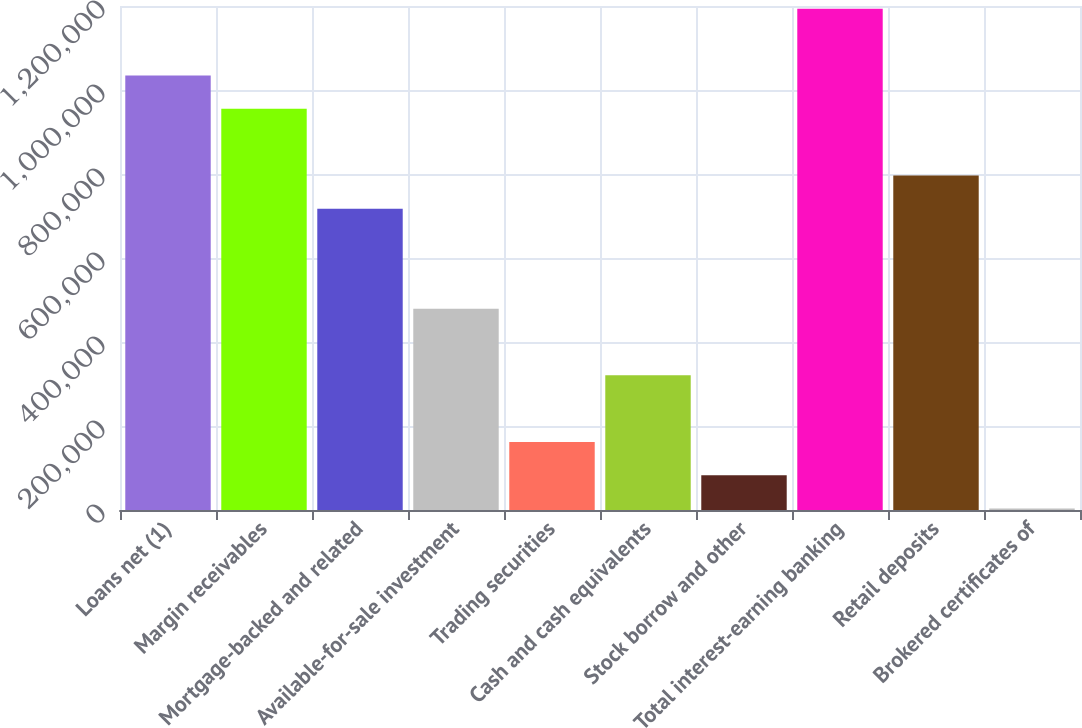Convert chart. <chart><loc_0><loc_0><loc_500><loc_500><bar_chart><fcel>Loans net (1)<fcel>Margin receivables<fcel>Mortgage-backed and related<fcel>Available-for-sale investment<fcel>Trading securities<fcel>Cash and cash equivalents<fcel>Stock borrow and other<fcel>Total interest-earning banking<fcel>Retail deposits<fcel>Brokered certificates of<nl><fcel>1.03458e+06<fcel>955249<fcel>717269<fcel>479289<fcel>161982<fcel>320636<fcel>82655.7<fcel>1.19323e+06<fcel>796596<fcel>3329<nl></chart> 